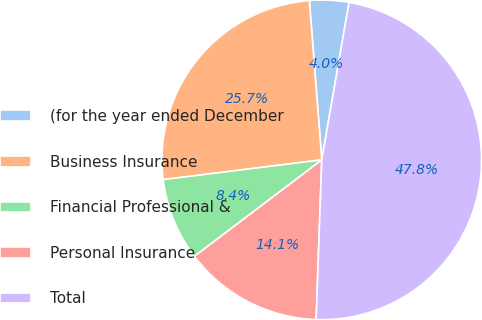Convert chart. <chart><loc_0><loc_0><loc_500><loc_500><pie_chart><fcel>(for the year ended December<fcel>Business Insurance<fcel>Financial Professional &<fcel>Personal Insurance<fcel>Total<nl><fcel>3.97%<fcel>25.73%<fcel>8.35%<fcel>14.12%<fcel>47.83%<nl></chart> 